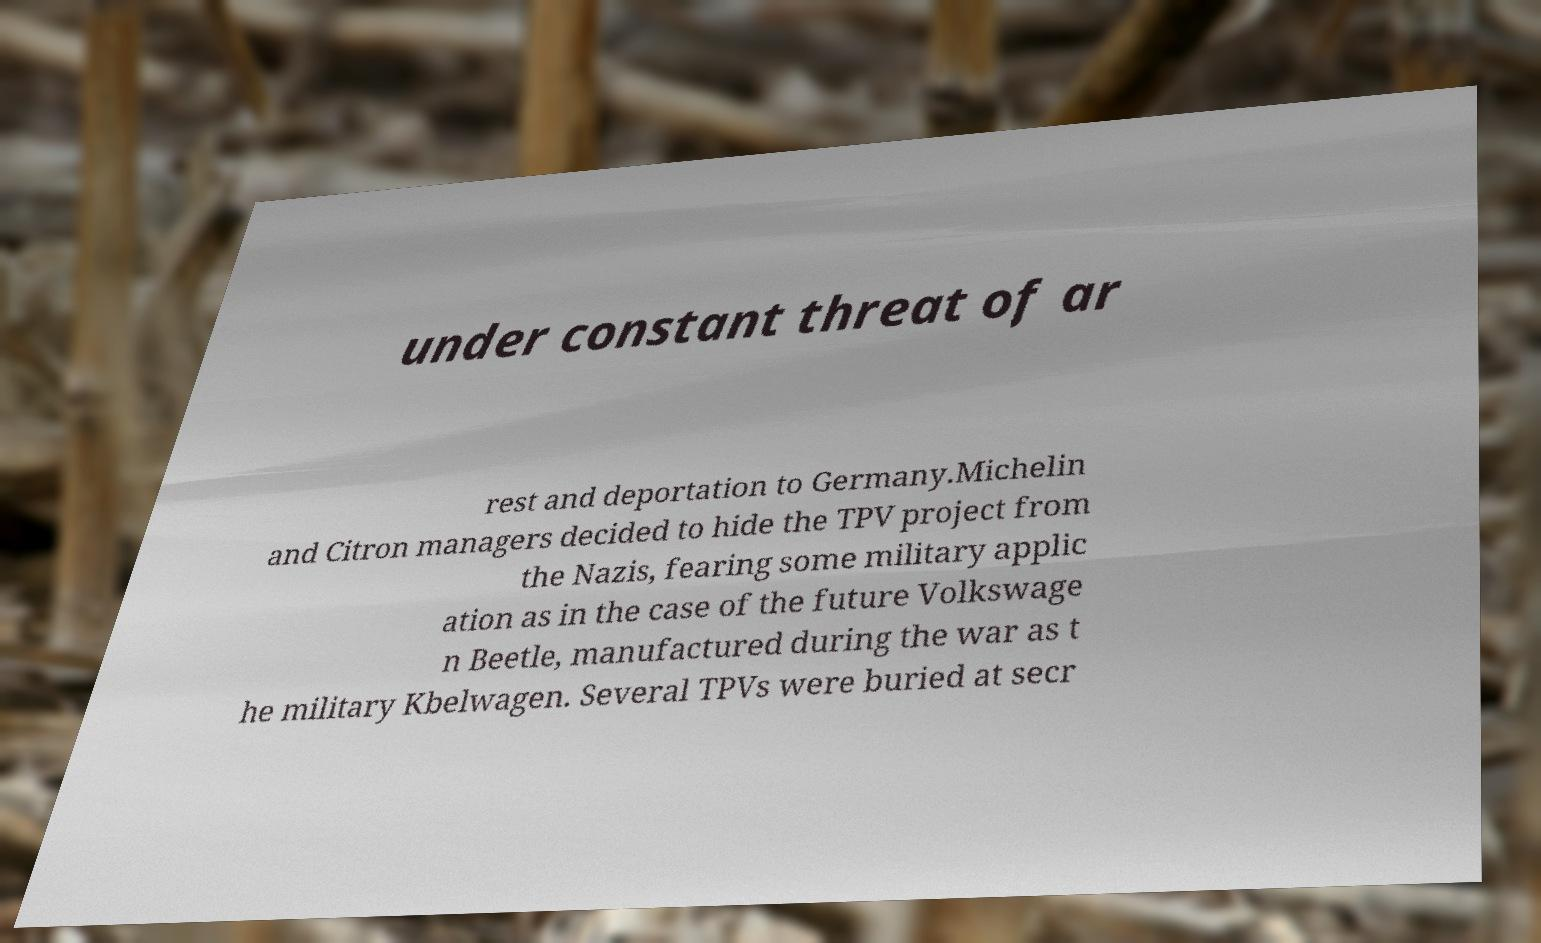Could you extract and type out the text from this image? under constant threat of ar rest and deportation to Germany.Michelin and Citron managers decided to hide the TPV project from the Nazis, fearing some military applic ation as in the case of the future Volkswage n Beetle, manufactured during the war as t he military Kbelwagen. Several TPVs were buried at secr 